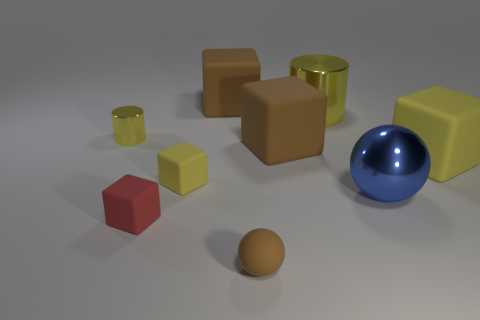Subtract all yellow cubes. How many were subtracted if there are1yellow cubes left? 1 Subtract 2 cubes. How many cubes are left? 3 Subtract all large yellow cubes. How many cubes are left? 4 Subtract all red cubes. How many cubes are left? 4 Subtract all green blocks. Subtract all red cylinders. How many blocks are left? 5 Add 1 small yellow rubber things. How many objects exist? 10 Subtract all cylinders. How many objects are left? 7 Add 2 large brown cubes. How many large brown cubes exist? 4 Subtract 0 cyan blocks. How many objects are left? 9 Subtract all tiny red rubber objects. Subtract all red matte things. How many objects are left? 7 